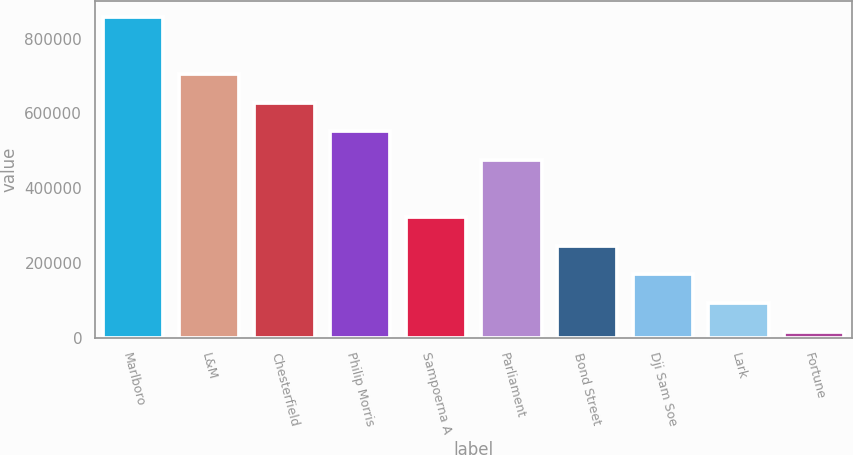<chart> <loc_0><loc_0><loc_500><loc_500><bar_chart><fcel>Marlboro<fcel>L&M<fcel>Chesterfield<fcel>Philip Morris<fcel>Sampoerna A<fcel>Parliament<fcel>Bond Street<fcel>Dji Sam Soe<fcel>Lark<fcel>Fortune<nl><fcel>858196<fcel>705178<fcel>628669<fcel>552160<fcel>322632<fcel>475651<fcel>246123<fcel>169614<fcel>93105.1<fcel>16596<nl></chart> 